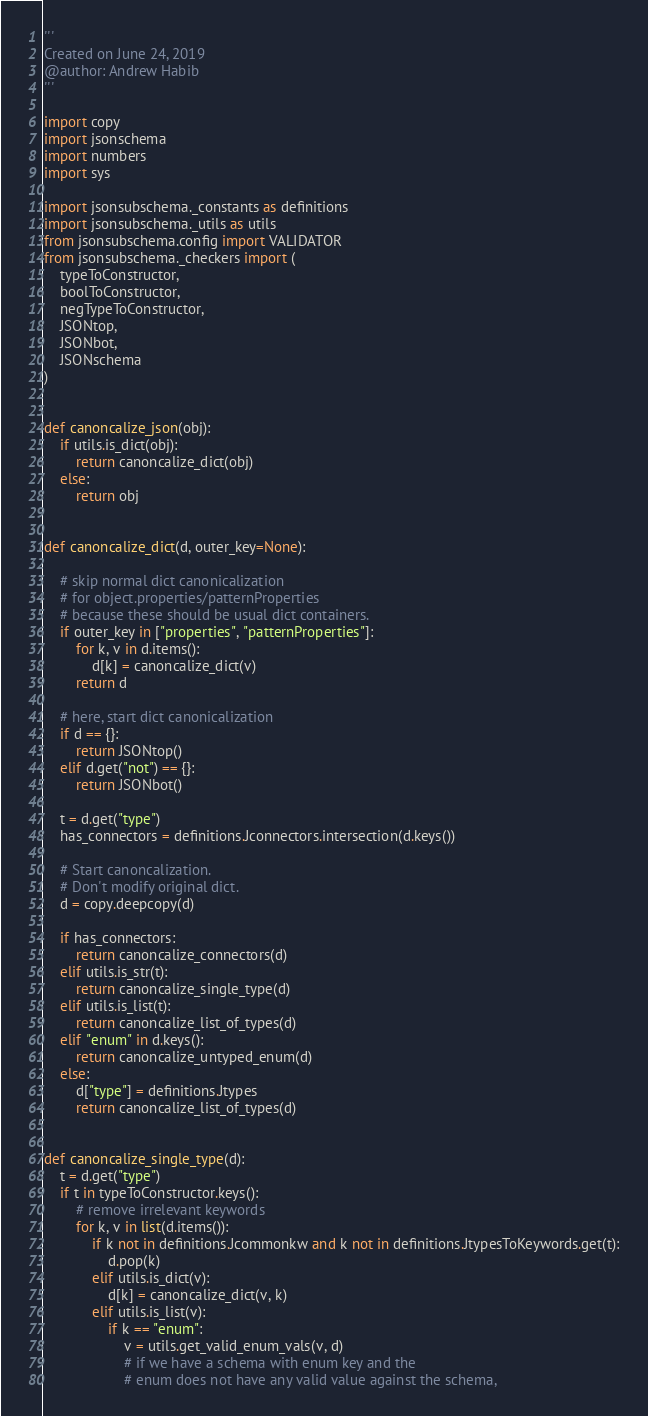<code> <loc_0><loc_0><loc_500><loc_500><_Python_>'''
Created on June 24, 2019
@author: Andrew Habib
'''

import copy
import jsonschema
import numbers
import sys

import jsonsubschema._constants as definitions
import jsonsubschema._utils as utils
from jsonsubschema.config import VALIDATOR
from jsonsubschema._checkers import (
    typeToConstructor,
    boolToConstructor,
    negTypeToConstructor,
    JSONtop,
    JSONbot,
    JSONschema
)


def canoncalize_json(obj):
    if utils.is_dict(obj):
        return canoncalize_dict(obj)
    else:
        return obj


def canoncalize_dict(d, outer_key=None):

    # skip normal dict canonicalization
    # for object.properties/patternProperties
    # because these should be usual dict containers.
    if outer_key in ["properties", "patternProperties"]:
        for k, v in d.items():
            d[k] = canoncalize_dict(v)
        return d

    # here, start dict canonicalization
    if d == {}:
        return JSONtop()
    elif d.get("not") == {}:
        return JSONbot()

    t = d.get("type")
    has_connectors = definitions.Jconnectors.intersection(d.keys())

    # Start canoncalization.
    # Don't modify original dict.
    d = copy.deepcopy(d)

    if has_connectors:
        return canoncalize_connectors(d)
    elif utils.is_str(t):
        return canoncalize_single_type(d)
    elif utils.is_list(t):
        return canoncalize_list_of_types(d)
    elif "enum" in d.keys():
        return canoncalize_untyped_enum(d)
    else:
        d["type"] = definitions.Jtypes
        return canoncalize_list_of_types(d)


def canoncalize_single_type(d):
    t = d.get("type")
    if t in typeToConstructor.keys():
        # remove irrelevant keywords
        for k, v in list(d.items()):
            if k not in definitions.Jcommonkw and k not in definitions.JtypesToKeywords.get(t):
                d.pop(k)
            elif utils.is_dict(v):
                d[k] = canoncalize_dict(v, k)
            elif utils.is_list(v):
                if k == "enum":
                    v = utils.get_valid_enum_vals(v, d)
                    # if we have a schema with enum key and the
                    # enum does not have any valid value against the schema,</code> 